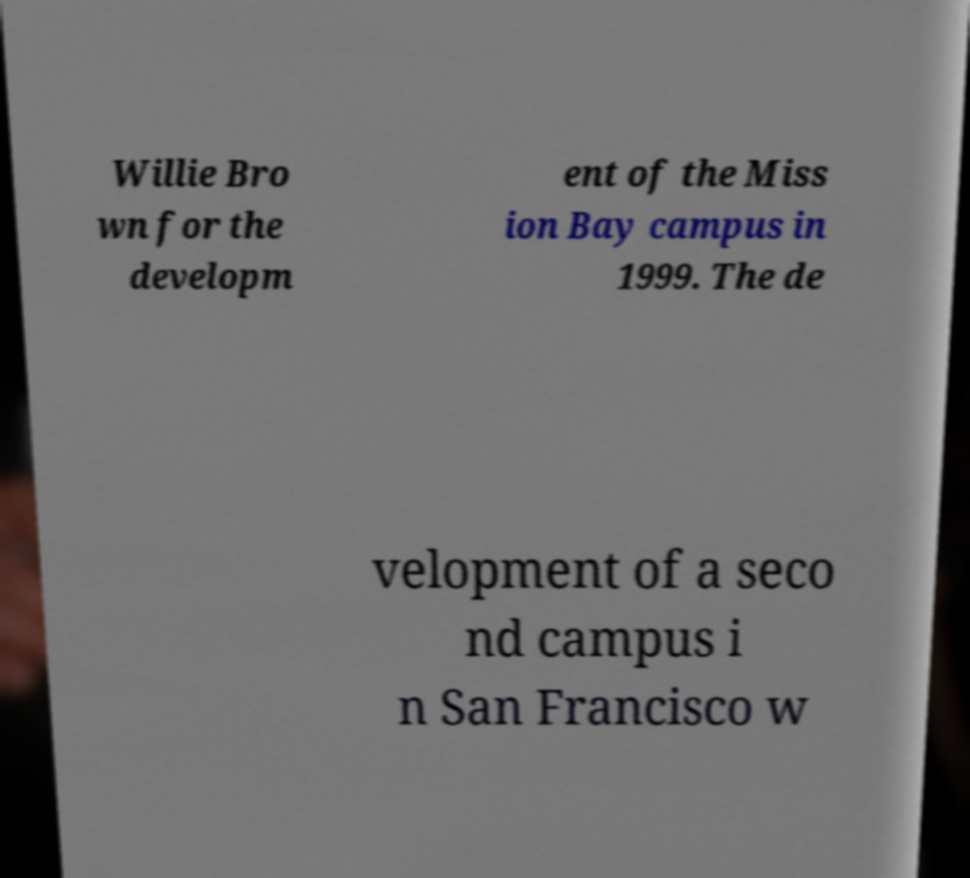What messages or text are displayed in this image? I need them in a readable, typed format. Willie Bro wn for the developm ent of the Miss ion Bay campus in 1999. The de velopment of a seco nd campus i n San Francisco w 